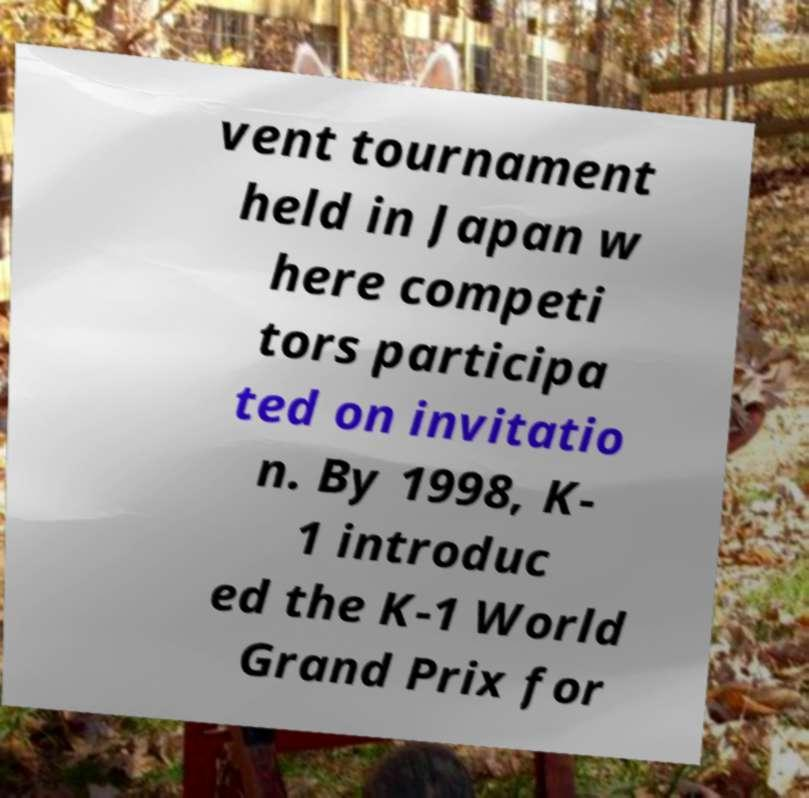What messages or text are displayed in this image? I need them in a readable, typed format. vent tournament held in Japan w here competi tors participa ted on invitatio n. By 1998, K- 1 introduc ed the K-1 World Grand Prix for 